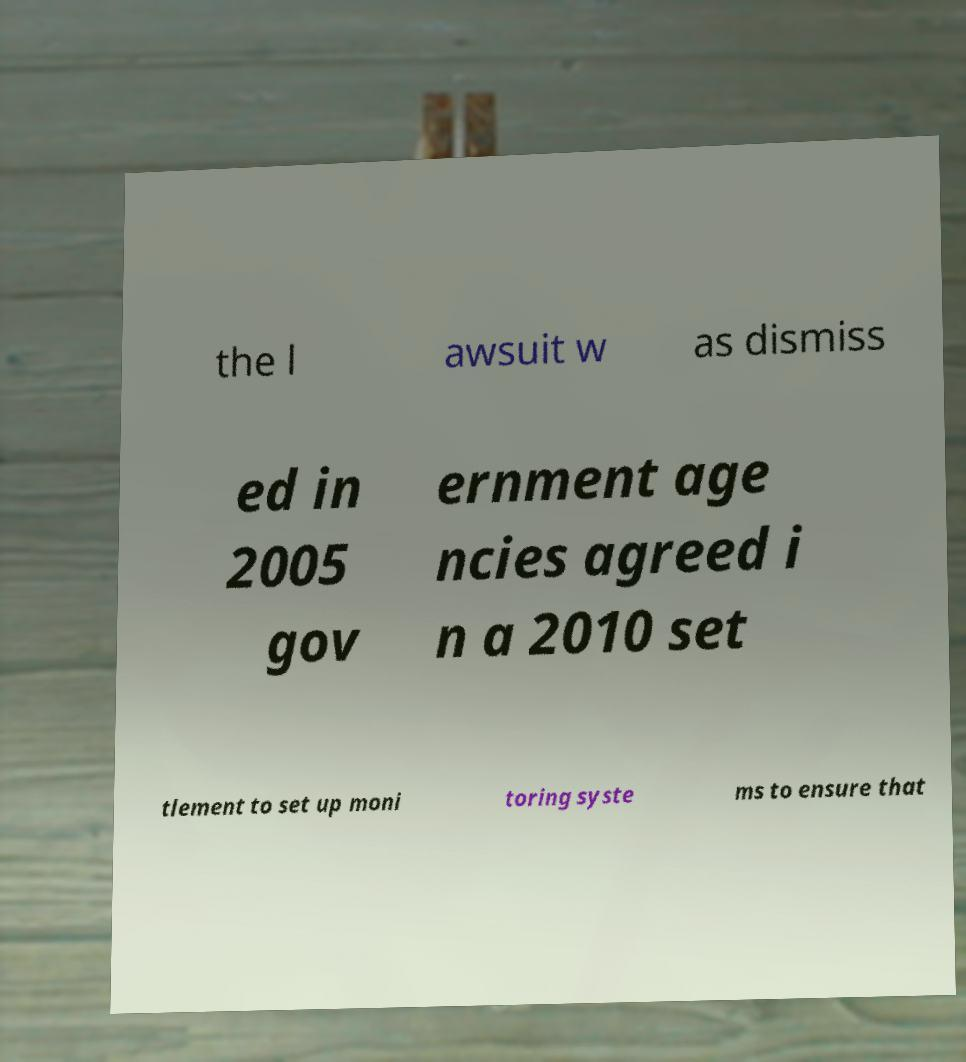Could you extract and type out the text from this image? the l awsuit w as dismiss ed in 2005 gov ernment age ncies agreed i n a 2010 set tlement to set up moni toring syste ms to ensure that 